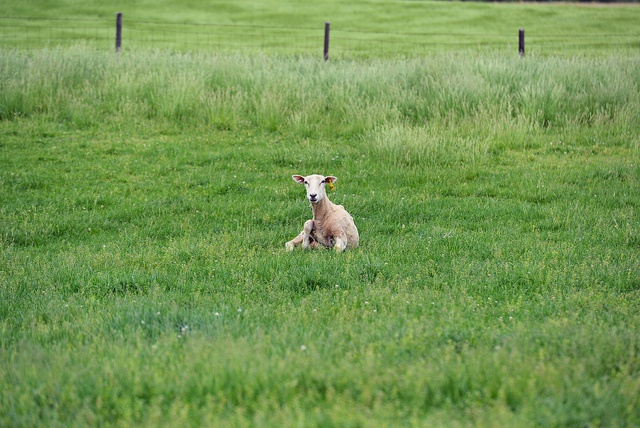Describe the objects in this image and their specific colors. I can see a sheep in olive, lightgray, darkgray, and tan tones in this image. 